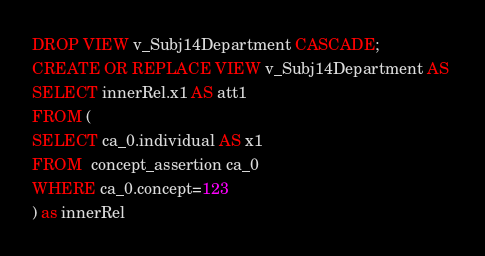<code> <loc_0><loc_0><loc_500><loc_500><_SQL_>DROP VIEW v_Subj14Department CASCADE;
CREATE OR REPLACE VIEW v_Subj14Department AS 
SELECT innerRel.x1 AS att1
FROM (
SELECT ca_0.individual AS x1
FROM  concept_assertion ca_0
WHERE ca_0.concept=123
) as innerRel
</code> 